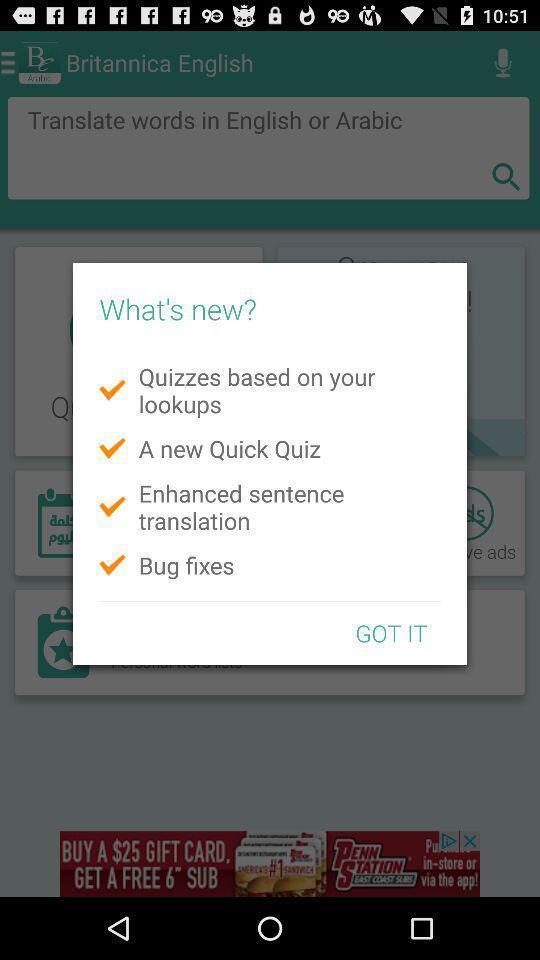Describe the key features of this screenshot. Pop-up displaying updates about the app. 